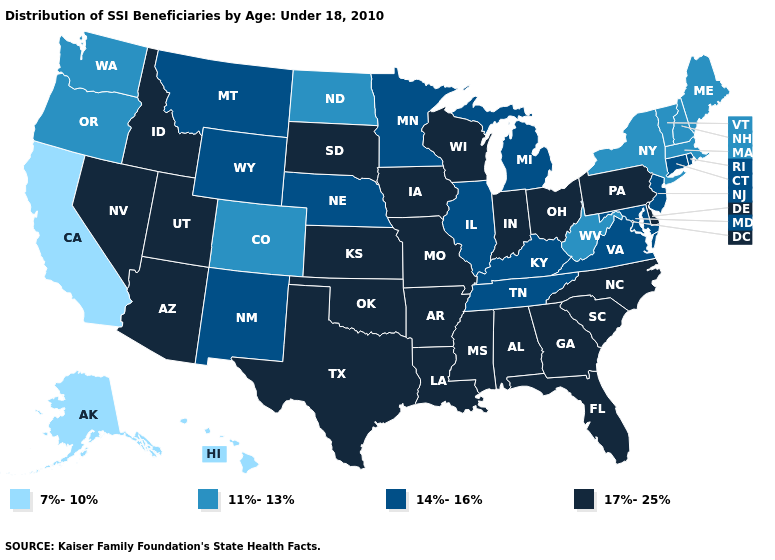Name the states that have a value in the range 7%-10%?
Keep it brief. Alaska, California, Hawaii. What is the highest value in the South ?
Be succinct. 17%-25%. What is the value of Oklahoma?
Write a very short answer. 17%-25%. What is the value of Oklahoma?
Answer briefly. 17%-25%. Name the states that have a value in the range 17%-25%?
Write a very short answer. Alabama, Arizona, Arkansas, Delaware, Florida, Georgia, Idaho, Indiana, Iowa, Kansas, Louisiana, Mississippi, Missouri, Nevada, North Carolina, Ohio, Oklahoma, Pennsylvania, South Carolina, South Dakota, Texas, Utah, Wisconsin. Name the states that have a value in the range 17%-25%?
Short answer required. Alabama, Arizona, Arkansas, Delaware, Florida, Georgia, Idaho, Indiana, Iowa, Kansas, Louisiana, Mississippi, Missouri, Nevada, North Carolina, Ohio, Oklahoma, Pennsylvania, South Carolina, South Dakota, Texas, Utah, Wisconsin. Among the states that border New Mexico , does Colorado have the highest value?
Short answer required. No. Is the legend a continuous bar?
Be succinct. No. Does the map have missing data?
Quick response, please. No. Name the states that have a value in the range 11%-13%?
Quick response, please. Colorado, Maine, Massachusetts, New Hampshire, New York, North Dakota, Oregon, Vermont, Washington, West Virginia. What is the value of Idaho?
Keep it brief. 17%-25%. Does Nebraska have the highest value in the USA?
Quick response, please. No. Name the states that have a value in the range 11%-13%?
Write a very short answer. Colorado, Maine, Massachusetts, New Hampshire, New York, North Dakota, Oregon, Vermont, Washington, West Virginia. What is the lowest value in the Northeast?
Answer briefly. 11%-13%. Which states have the lowest value in the USA?
Concise answer only. Alaska, California, Hawaii. 